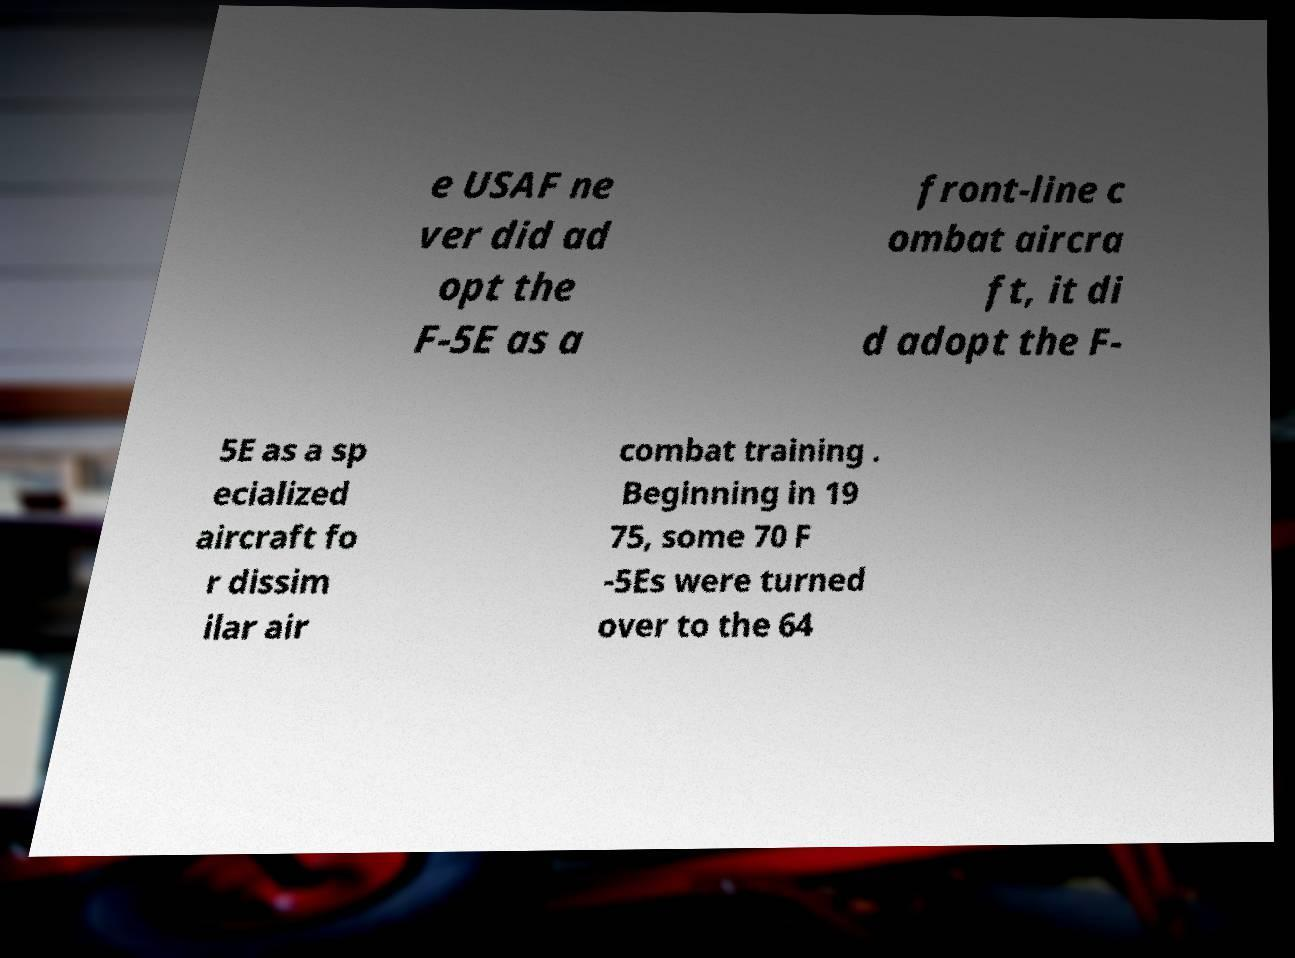What messages or text are displayed in this image? I need them in a readable, typed format. e USAF ne ver did ad opt the F-5E as a front-line c ombat aircra ft, it di d adopt the F- 5E as a sp ecialized aircraft fo r dissim ilar air combat training . Beginning in 19 75, some 70 F -5Es were turned over to the 64 